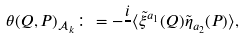Convert formula to latex. <formula><loc_0><loc_0><loc_500><loc_500>\theta ( Q , P ) _ { \mathcal { A } _ { k } } \colon = - \frac { i } { } \langle \tilde { \xi } ^ { a _ { 1 } } ( Q ) \tilde { \eta } _ { a _ { 2 } } ( P ) \rangle ,</formula> 